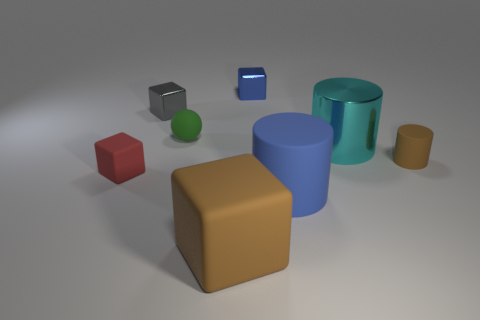Subtract all large cylinders. How many cylinders are left? 1 Add 2 small metal blocks. How many objects exist? 10 Subtract all gray cubes. How many cubes are left? 3 Add 2 big things. How many big things exist? 5 Subtract 0 red balls. How many objects are left? 8 Subtract all cylinders. How many objects are left? 5 Subtract all green blocks. Subtract all blue cylinders. How many blocks are left? 4 Subtract all red rubber cubes. Subtract all cyan metal spheres. How many objects are left? 7 Add 6 large cyan things. How many large cyan things are left? 7 